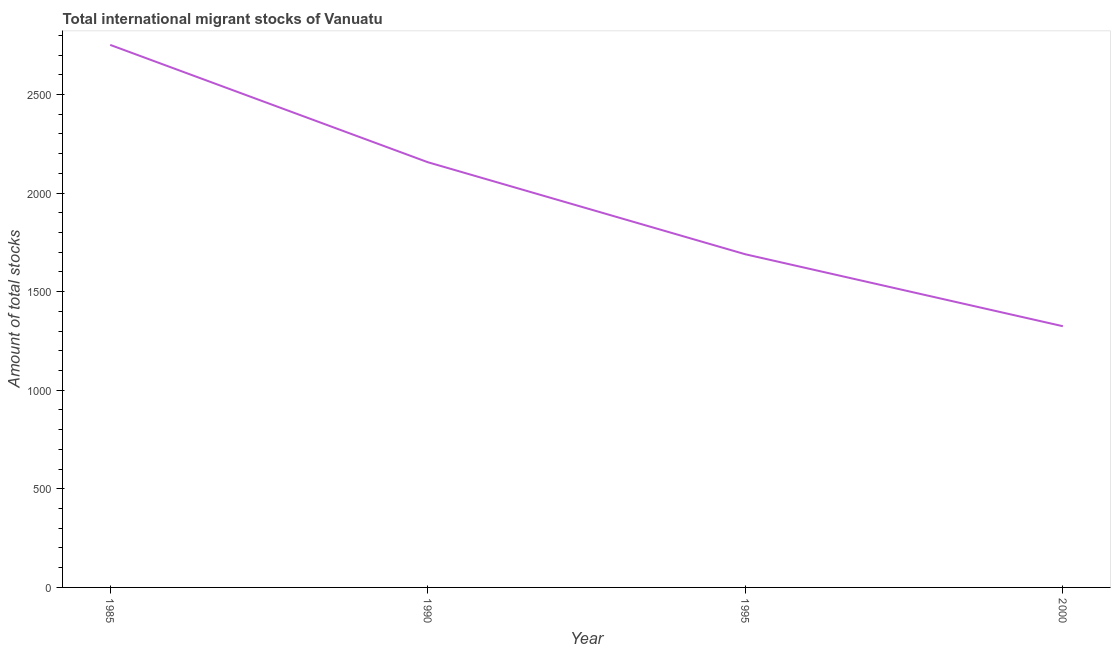What is the total number of international migrant stock in 2000?
Ensure brevity in your answer.  1325. Across all years, what is the maximum total number of international migrant stock?
Make the answer very short. 2752. Across all years, what is the minimum total number of international migrant stock?
Your answer should be very brief. 1325. In which year was the total number of international migrant stock minimum?
Offer a very short reply. 2000. What is the sum of the total number of international migrant stock?
Provide a short and direct response. 7924. What is the difference between the total number of international migrant stock in 1985 and 1995?
Provide a succinct answer. 1062. What is the average total number of international migrant stock per year?
Give a very brief answer. 1981. What is the median total number of international migrant stock?
Your answer should be compact. 1923.5. In how many years, is the total number of international migrant stock greater than 600 ?
Your answer should be very brief. 4. Do a majority of the years between 1995 and 1985 (inclusive) have total number of international migrant stock greater than 900 ?
Your answer should be compact. No. What is the ratio of the total number of international migrant stock in 1985 to that in 1995?
Offer a terse response. 1.63. Is the total number of international migrant stock in 1990 less than that in 1995?
Your answer should be compact. No. Is the difference between the total number of international migrant stock in 1995 and 2000 greater than the difference between any two years?
Make the answer very short. No. What is the difference between the highest and the second highest total number of international migrant stock?
Provide a succinct answer. 595. Is the sum of the total number of international migrant stock in 1985 and 1995 greater than the maximum total number of international migrant stock across all years?
Make the answer very short. Yes. What is the difference between the highest and the lowest total number of international migrant stock?
Provide a succinct answer. 1427. How many lines are there?
Your answer should be compact. 1. What is the difference between two consecutive major ticks on the Y-axis?
Your response must be concise. 500. Does the graph contain any zero values?
Give a very brief answer. No. What is the title of the graph?
Provide a short and direct response. Total international migrant stocks of Vanuatu. What is the label or title of the X-axis?
Offer a very short reply. Year. What is the label or title of the Y-axis?
Your answer should be compact. Amount of total stocks. What is the Amount of total stocks in 1985?
Provide a short and direct response. 2752. What is the Amount of total stocks in 1990?
Your answer should be very brief. 2157. What is the Amount of total stocks in 1995?
Your response must be concise. 1690. What is the Amount of total stocks of 2000?
Keep it short and to the point. 1325. What is the difference between the Amount of total stocks in 1985 and 1990?
Give a very brief answer. 595. What is the difference between the Amount of total stocks in 1985 and 1995?
Your response must be concise. 1062. What is the difference between the Amount of total stocks in 1985 and 2000?
Provide a succinct answer. 1427. What is the difference between the Amount of total stocks in 1990 and 1995?
Make the answer very short. 467. What is the difference between the Amount of total stocks in 1990 and 2000?
Offer a very short reply. 832. What is the difference between the Amount of total stocks in 1995 and 2000?
Keep it short and to the point. 365. What is the ratio of the Amount of total stocks in 1985 to that in 1990?
Your answer should be very brief. 1.28. What is the ratio of the Amount of total stocks in 1985 to that in 1995?
Offer a terse response. 1.63. What is the ratio of the Amount of total stocks in 1985 to that in 2000?
Offer a very short reply. 2.08. What is the ratio of the Amount of total stocks in 1990 to that in 1995?
Make the answer very short. 1.28. What is the ratio of the Amount of total stocks in 1990 to that in 2000?
Ensure brevity in your answer.  1.63. What is the ratio of the Amount of total stocks in 1995 to that in 2000?
Provide a succinct answer. 1.27. 